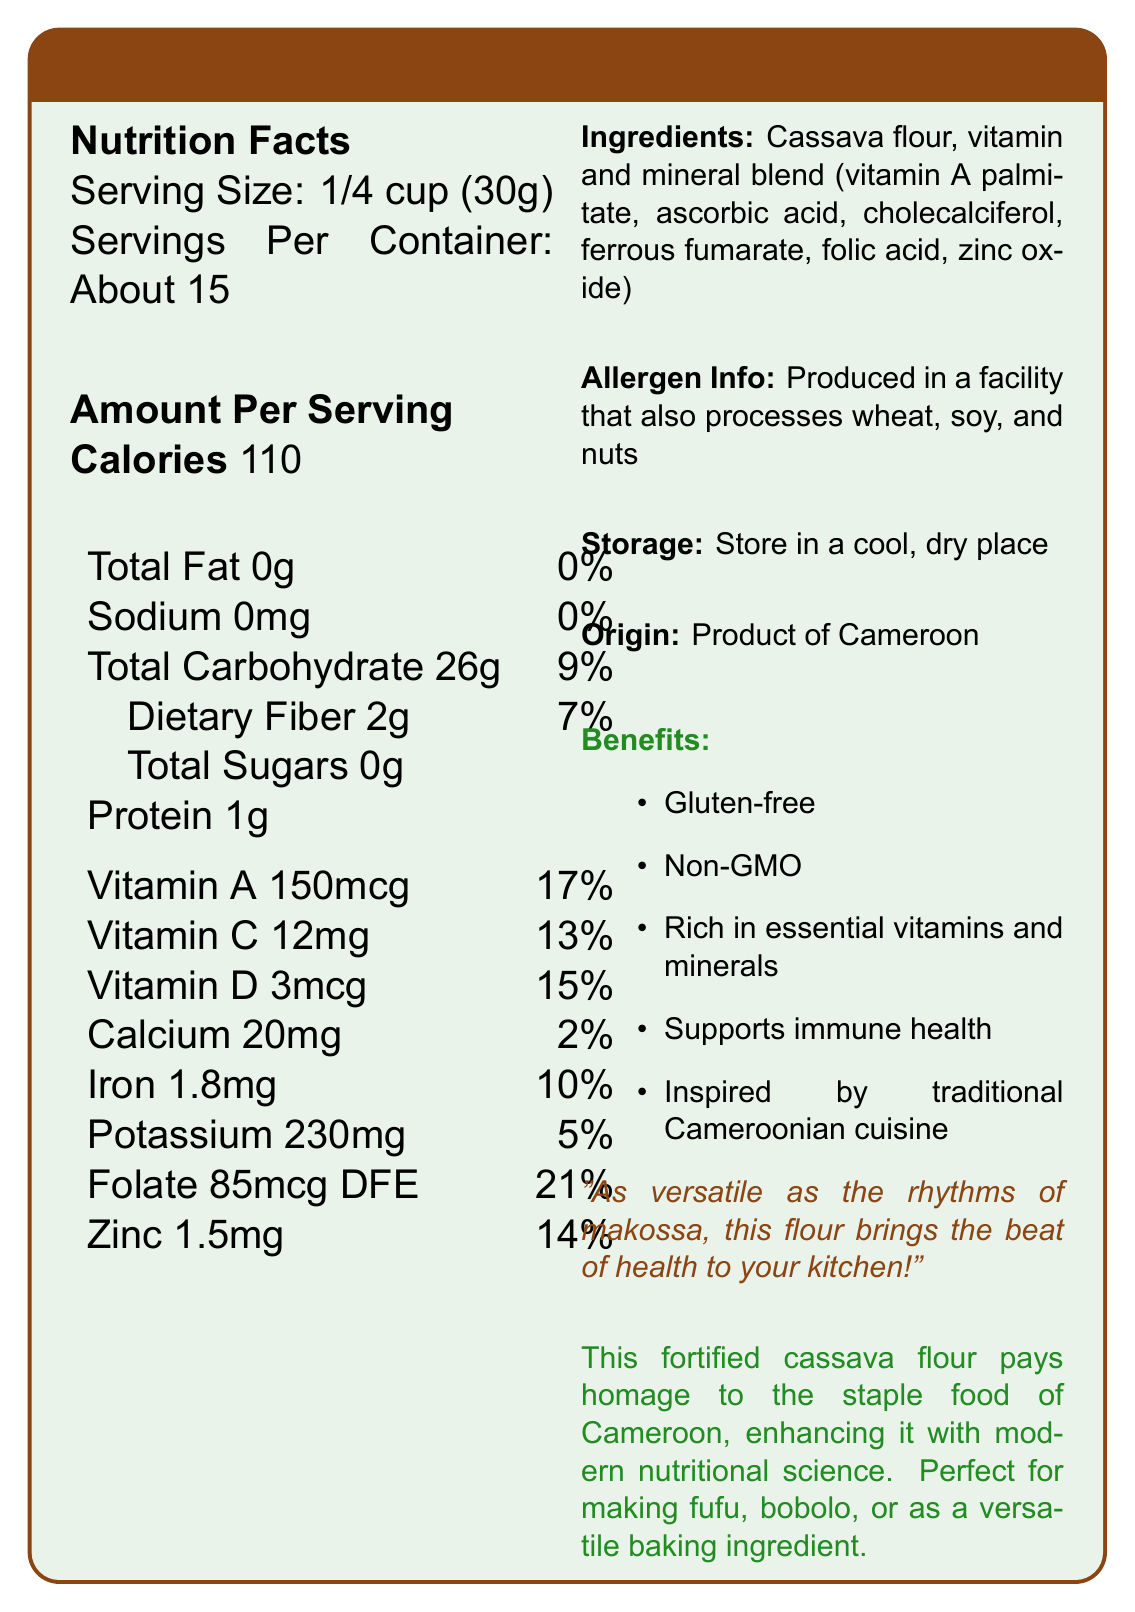How many servings are there per container? The document states that there are about 15 servings per container.
Answer: About 15 What is the serving size of VitaCassava Fortified Flour? The document mentions that the serving size is 1/4 cup, equivalent to 30g.
Answer: 1/4 cup (30g) How many calories are in one serving? The document lists the number of calories per serving as 110.
Answer: 110 calories What is the amount of dietary fiber per serving? The nutrition facts state that each serving has 2g of dietary fiber.
Answer: 2g What is the daily value percentage of vitamin A in one serving? The document indicates that one serving provides 17% of the daily value of vitamin A.
Answer: 17% Are there any allergens in VitaCassava Fortified Flour? The allergen info mentions that the flour is produced in a facility that processes wheat, soy, and nuts.
Answer: Produced in a facility that also processes wheat, soy, and nuts Which vitamins and minerals are particularly enriched in VitaCassava Fortified Flour? A. Vitamin B12, Magnesium, Copper B. Vitamin A, Vitamin C, Folate C. Vitamin E, Calcium, Potassium D. Thiamine, Niacin, Selenium The flour is enriched with several vitamins and minerals, prominently including Vitamin A (17% DV), Vitamin C (13% DV), and Folate (21% DV).
Answer: B. Vitamin A, Vitamin C, Folate What is the amount of iron per serving? A. 20mg B. 1.8mg C. 150mcg D. 2g The nutrition facts indicate that each serving contains 1.8mg of iron.
Answer: B. 1.8mg Is VitaCassava Fortified Flour gluten-free? One of the marketing claims listed is that the product is gluten-free.
Answer: Yes Can this flour be used for making traditional Cameroonian dishes like fufu and bobolo? The document notes that the flour is perfect for making traditional Cameroonian dishes like fufu and bobolo.
Answer: Yes Summarize the key features and benefits of VitaCassava Fortified Flour. The document highlights the flour's gluten-free and non-GMO nature, its rich vitamin and mineral content, its support for immune health, and its versatility in cooking traditional Cameroonian dishes. It also emphasizes that it contains no fat or sodium.
Answer: VitaCassava Fortified Flour is a nutritionally enhanced product inspired by traditional Cameroonian cuisine. It is gluten-free, non-GMO, and rich in essential vitamins and minerals like Vitamin A, Vitamin C, and Folate. It supports immune health and contains no total fat or sodium. The product is versatile for various recipes and promotes health with its enriched nutrient profile. What specific ingredient is used to enrich VitaCassava Fortified Flour with vitamin D? The document lists a vitamin and mineral blend but does not specify which ingredient is used for vitamin D enrichment.
Answer: Not enough information 